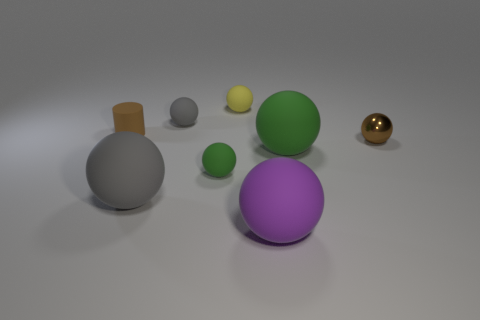Is there anything else that is the same material as the small brown ball?
Offer a terse response. No. What is the color of the tiny cylinder that is the same material as the large gray sphere?
Give a very brief answer. Brown. Does the gray matte thing that is in front of the tiny matte cylinder have the same shape as the purple matte object?
Offer a terse response. Yes. What number of things are tiny things that are in front of the small rubber cylinder or balls that are in front of the small brown matte cylinder?
Provide a short and direct response. 5. The metallic thing that is the same shape as the small green rubber thing is what color?
Your response must be concise. Brown. Is there anything else that is the same shape as the tiny gray object?
Your response must be concise. Yes. Is the shape of the tiny brown matte thing the same as the brown thing right of the tiny gray rubber sphere?
Give a very brief answer. No. What is the small yellow object made of?
Keep it short and to the point. Rubber. What size is the brown metallic object that is the same shape as the small yellow matte thing?
Offer a very short reply. Small. What number of other things are the same material as the tiny cylinder?
Your answer should be compact. 6. 